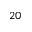<formula> <loc_0><loc_0><loc_500><loc_500>2 0</formula> 